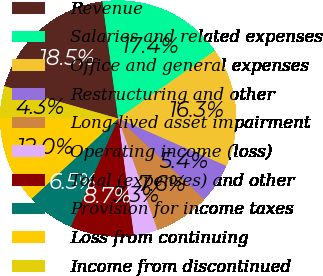Convert chart. <chart><loc_0><loc_0><loc_500><loc_500><pie_chart><fcel>Revenue<fcel>Salaries and related expenses<fcel>Office and general expenses<fcel>Restructuring and other<fcel>Long-lived asset impairment<fcel>Operating income (loss)<fcel>Total (expenses) and other<fcel>Provision for income taxes<fcel>Loss from continuing<fcel>Income from discontinued<nl><fcel>18.48%<fcel>17.39%<fcel>16.3%<fcel>5.43%<fcel>7.61%<fcel>3.26%<fcel>8.7%<fcel>6.52%<fcel>11.96%<fcel>4.35%<nl></chart> 